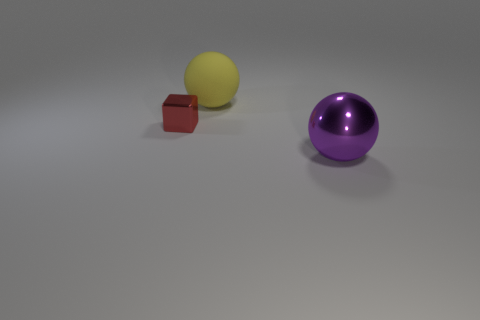Add 1 small red blocks. How many objects exist? 4 Subtract all cubes. How many objects are left? 2 Subtract 1 balls. How many balls are left? 1 Subtract all purple balls. How many balls are left? 1 Subtract all yellow spheres. Subtract all blue cubes. How many spheres are left? 1 Subtract all yellow things. Subtract all purple metallic spheres. How many objects are left? 1 Add 3 tiny metallic blocks. How many tiny metallic blocks are left? 4 Add 1 large green balls. How many large green balls exist? 1 Subtract 0 gray blocks. How many objects are left? 3 